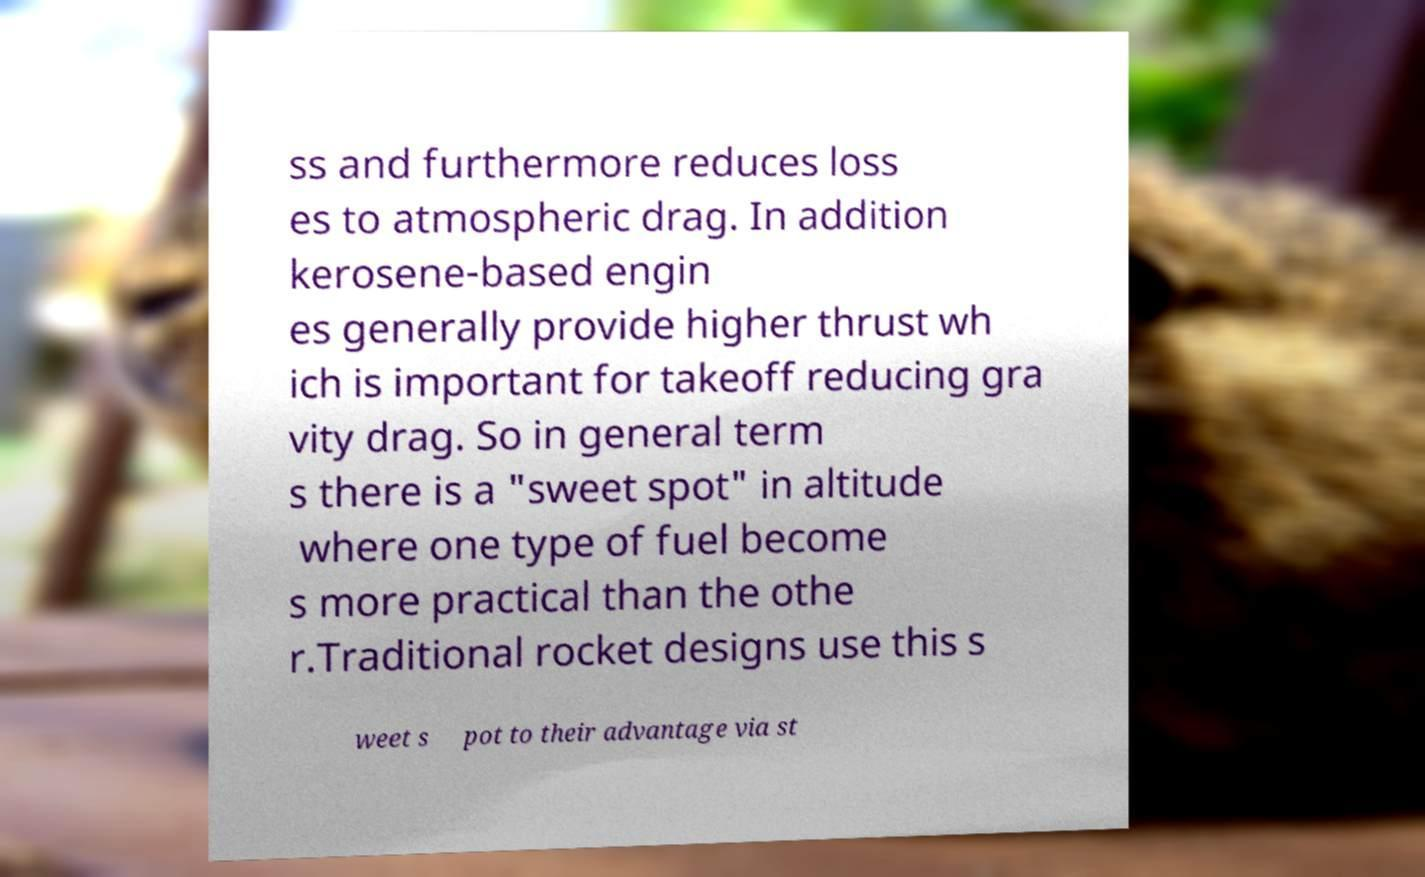There's text embedded in this image that I need extracted. Can you transcribe it verbatim? ss and furthermore reduces loss es to atmospheric drag. In addition kerosene-based engin es generally provide higher thrust wh ich is important for takeoff reducing gra vity drag. So in general term s there is a "sweet spot" in altitude where one type of fuel become s more practical than the othe r.Traditional rocket designs use this s weet s pot to their advantage via st 